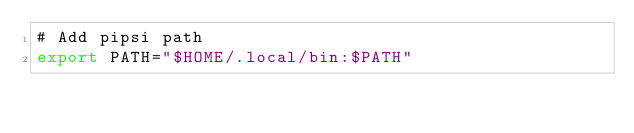<code> <loc_0><loc_0><loc_500><loc_500><_Bash_># Add pipsi path
export PATH="$HOME/.local/bin:$PATH"</code> 